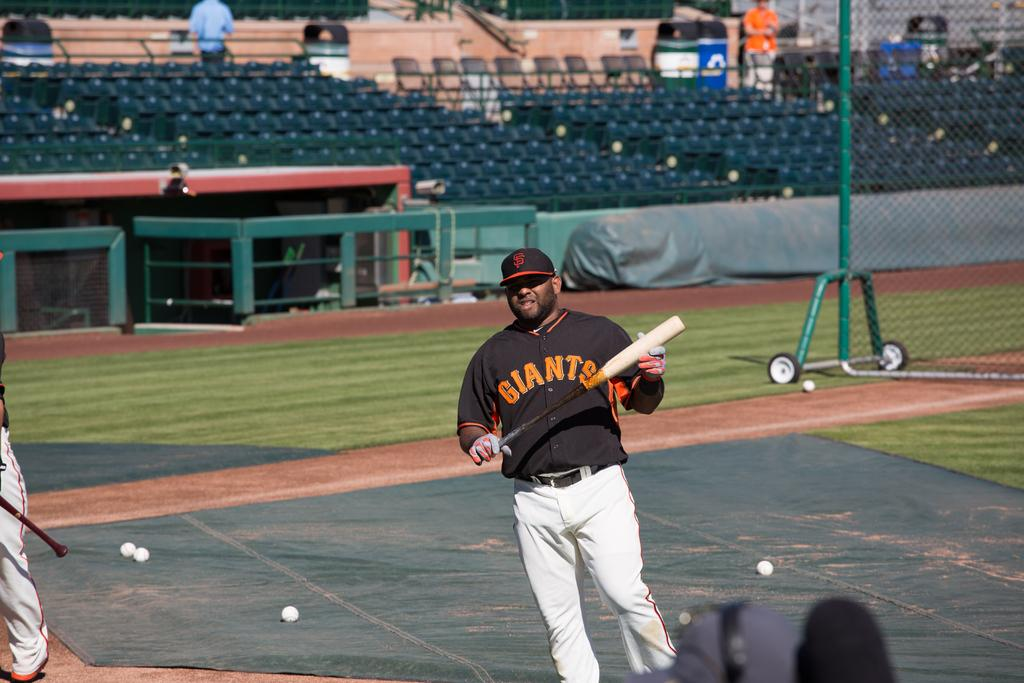<image>
Describe the image concisely. A baseball player wearing a jersey depicting the name Giants on the front holds a baseball bat. 